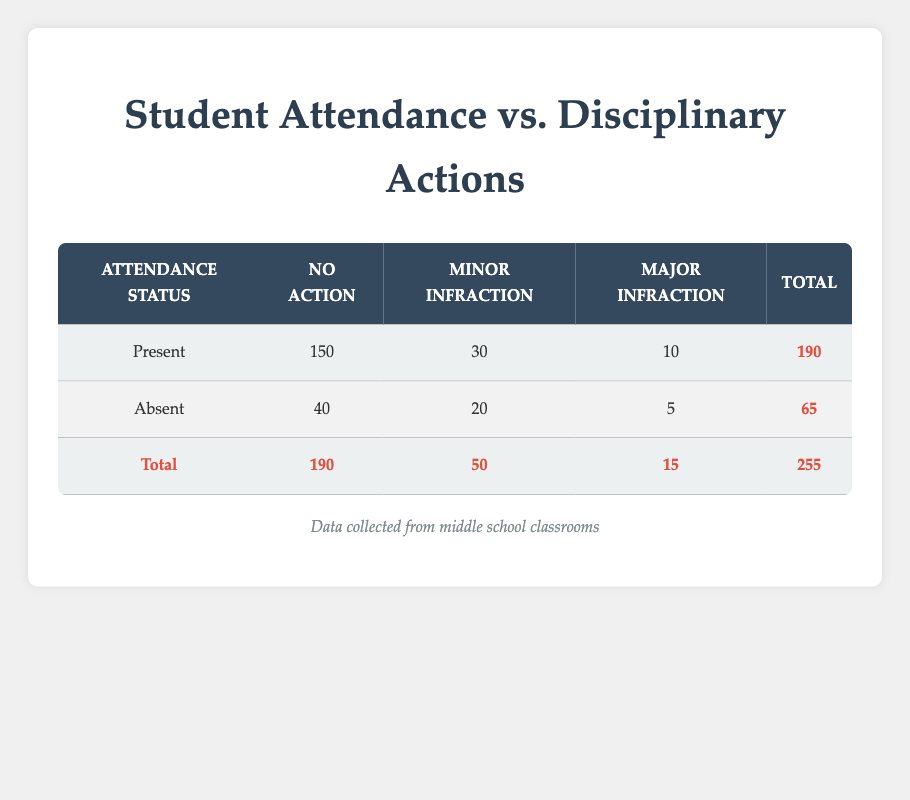What is the total number of students present in the classroom? The table shows that the total count of students with "Present" attendance status is 190. This value can be found in the "Total" column of the row corresponding to "Present."
Answer: 190 How many students had a minor infraction while present? According to the table, 30 students who were "Present" had a "Minor Infraction." This figure is directly taken from the respective row.
Answer: 30 Is it true that the number of students absent with no disciplinary actions taken is greater than those present with a major infraction? The table shows 40 students were absent with no disciplinary actions taken, while only 10 students were present with a major infraction. Since 40 is greater than 10, the statement is true.
Answer: Yes What is the total number of students who received disciplinary action, either minor or major, while being present? To find this total, sum the numbers of students with a "Minor Infraction" (30) and a "Major Infraction" (10) under the "Present" attendance status. Therefore, 30 + 10 = 40.
Answer: 40 What is the ratio of students present with no action taken to those absent with minor infractions? The count for "Present" students with no action is 150, while for "Absent" students with a minor infraction it is 20. The ratio is calculated as 150:20, which simplifies to 15:2.
Answer: 15:2 How many more students were present with no disciplinary actions than those who were absent with any disciplinary action? The number of present students with no disciplinary actions is 150, while the absence group has a total of 25 students who received disciplinary actions (20 with minor infractions and 5 with major infractions). The difference is 150 - 25 = 125.
Answer: 125 